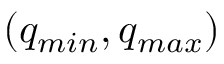<formula> <loc_0><loc_0><loc_500><loc_500>( q _ { \min } , q _ { \max } )</formula> 